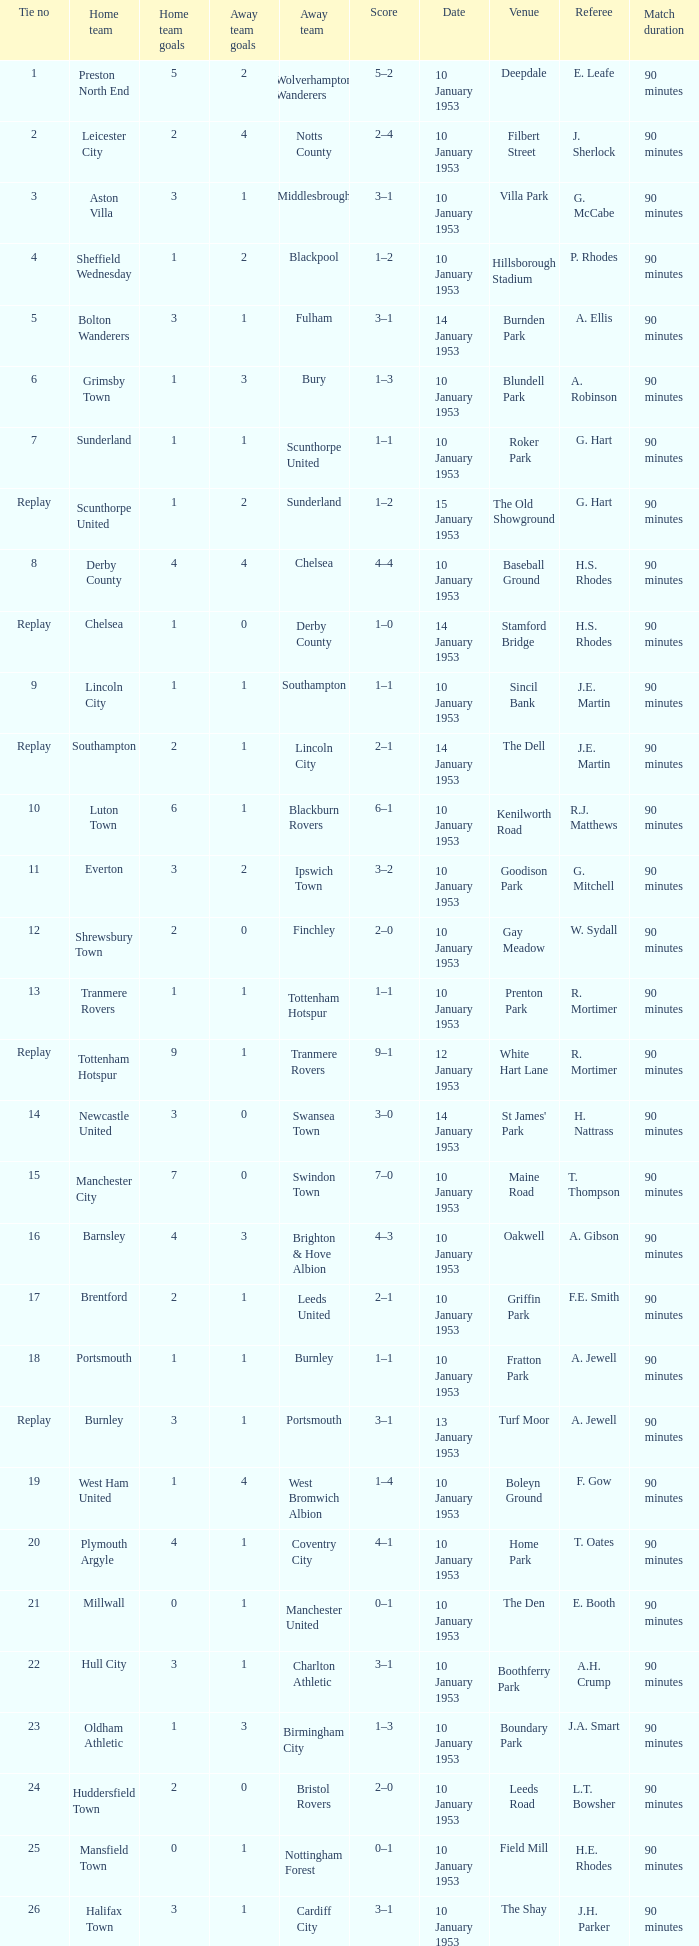What home team has coventry city as the away team? Plymouth Argyle. 